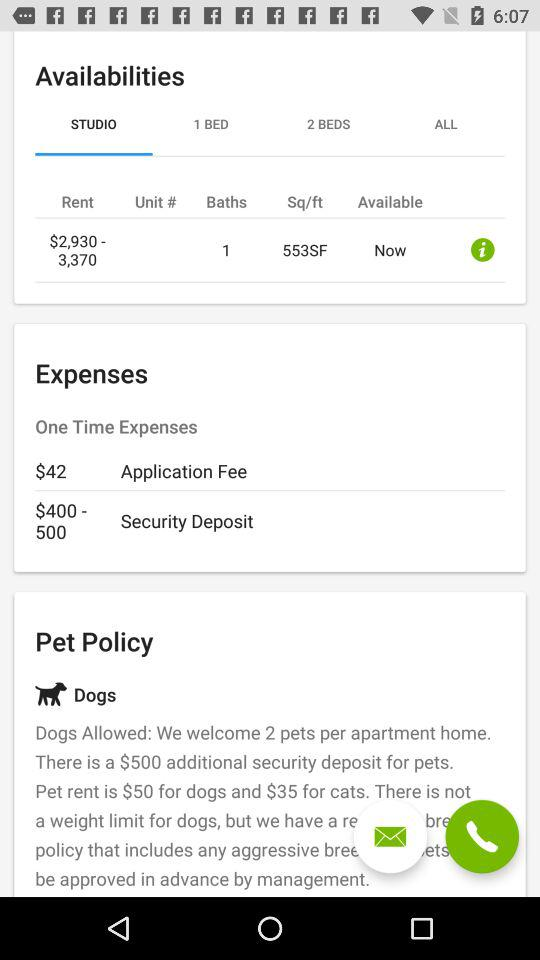What is the rent? The rent ranges from $2,930 to $3,370. 